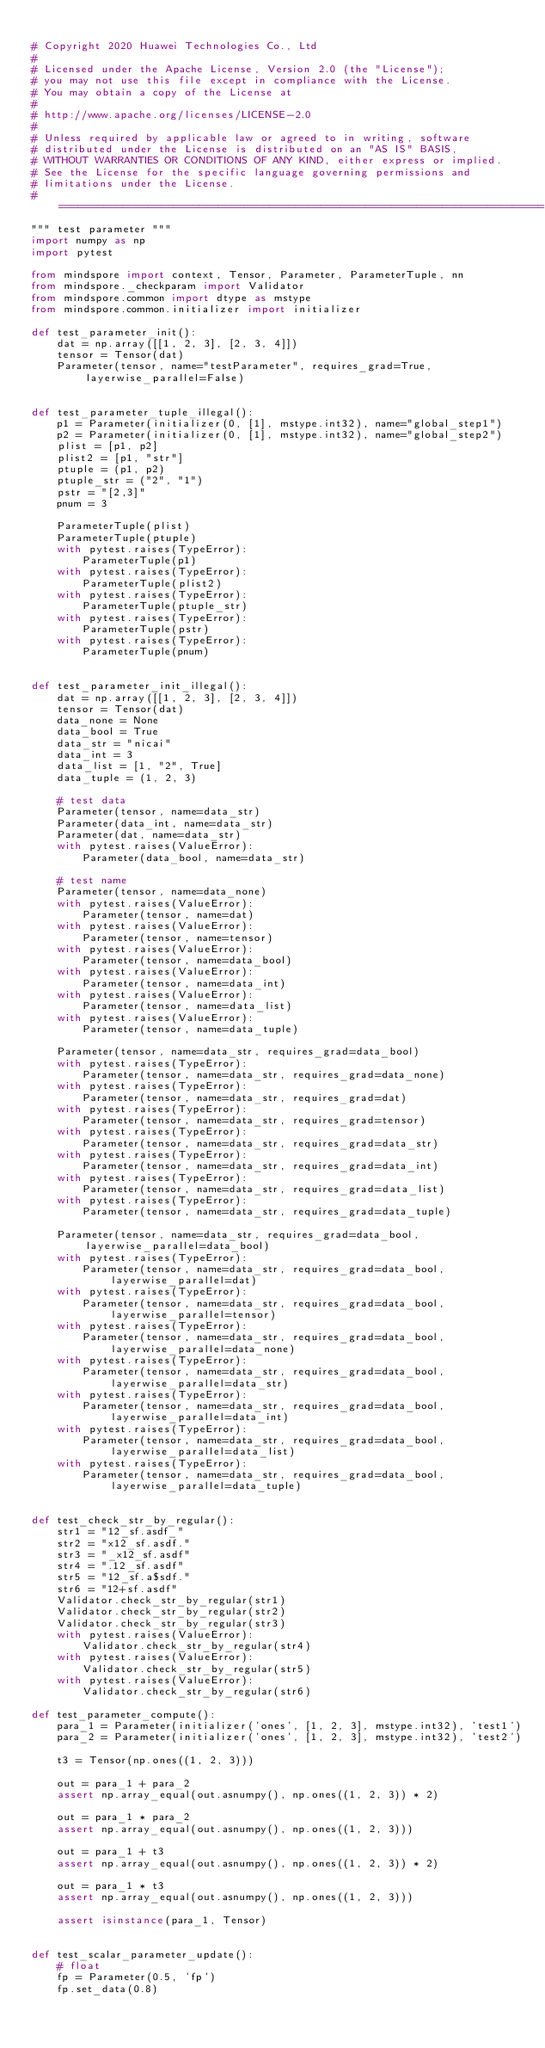<code> <loc_0><loc_0><loc_500><loc_500><_Python_>
# Copyright 2020 Huawei Technologies Co., Ltd
#
# Licensed under the Apache License, Version 2.0 (the "License");
# you may not use this file except in compliance with the License.
# You may obtain a copy of the License at
#
# http://www.apache.org/licenses/LICENSE-2.0
#
# Unless required by applicable law or agreed to in writing, software
# distributed under the License is distributed on an "AS IS" BASIS,
# WITHOUT WARRANTIES OR CONDITIONS OF ANY KIND, either express or implied.
# See the License for the specific language governing permissions and
# limitations under the License.
# ============================================================================
""" test parameter """
import numpy as np
import pytest

from mindspore import context, Tensor, Parameter, ParameterTuple, nn
from mindspore._checkparam import Validator
from mindspore.common import dtype as mstype
from mindspore.common.initializer import initializer

def test_parameter_init():
    dat = np.array([[1, 2, 3], [2, 3, 4]])
    tensor = Tensor(dat)
    Parameter(tensor, name="testParameter", requires_grad=True, layerwise_parallel=False)


def test_parameter_tuple_illegal():
    p1 = Parameter(initializer(0, [1], mstype.int32), name="global_step1")
    p2 = Parameter(initializer(0, [1], mstype.int32), name="global_step2")
    plist = [p1, p2]
    plist2 = [p1, "str"]
    ptuple = (p1, p2)
    ptuple_str = ("2", "1")
    pstr = "[2,3]"
    pnum = 3

    ParameterTuple(plist)
    ParameterTuple(ptuple)
    with pytest.raises(TypeError):
        ParameterTuple(p1)
    with pytest.raises(TypeError):
        ParameterTuple(plist2)
    with pytest.raises(TypeError):
        ParameterTuple(ptuple_str)
    with pytest.raises(TypeError):
        ParameterTuple(pstr)
    with pytest.raises(TypeError):
        ParameterTuple(pnum)


def test_parameter_init_illegal():
    dat = np.array([[1, 2, 3], [2, 3, 4]])
    tensor = Tensor(dat)
    data_none = None
    data_bool = True
    data_str = "nicai"
    data_int = 3
    data_list = [1, "2", True]
    data_tuple = (1, 2, 3)

    # test data
    Parameter(tensor, name=data_str)
    Parameter(data_int, name=data_str)
    Parameter(dat, name=data_str)
    with pytest.raises(ValueError):
        Parameter(data_bool, name=data_str)

    # test name
    Parameter(tensor, name=data_none)
    with pytest.raises(ValueError):
        Parameter(tensor, name=dat)
    with pytest.raises(ValueError):
        Parameter(tensor, name=tensor)
    with pytest.raises(ValueError):
        Parameter(tensor, name=data_bool)
    with pytest.raises(ValueError):
        Parameter(tensor, name=data_int)
    with pytest.raises(ValueError):
        Parameter(tensor, name=data_list)
    with pytest.raises(ValueError):
        Parameter(tensor, name=data_tuple)

    Parameter(tensor, name=data_str, requires_grad=data_bool)
    with pytest.raises(TypeError):
        Parameter(tensor, name=data_str, requires_grad=data_none)
    with pytest.raises(TypeError):
        Parameter(tensor, name=data_str, requires_grad=dat)
    with pytest.raises(TypeError):
        Parameter(tensor, name=data_str, requires_grad=tensor)
    with pytest.raises(TypeError):
        Parameter(tensor, name=data_str, requires_grad=data_str)
    with pytest.raises(TypeError):
        Parameter(tensor, name=data_str, requires_grad=data_int)
    with pytest.raises(TypeError):
        Parameter(tensor, name=data_str, requires_grad=data_list)
    with pytest.raises(TypeError):
        Parameter(tensor, name=data_str, requires_grad=data_tuple)

    Parameter(tensor, name=data_str, requires_grad=data_bool, layerwise_parallel=data_bool)
    with pytest.raises(TypeError):
        Parameter(tensor, name=data_str, requires_grad=data_bool, layerwise_parallel=dat)
    with pytest.raises(TypeError):
        Parameter(tensor, name=data_str, requires_grad=data_bool, layerwise_parallel=tensor)
    with pytest.raises(TypeError):
        Parameter(tensor, name=data_str, requires_grad=data_bool, layerwise_parallel=data_none)
    with pytest.raises(TypeError):
        Parameter(tensor, name=data_str, requires_grad=data_bool, layerwise_parallel=data_str)
    with pytest.raises(TypeError):
        Parameter(tensor, name=data_str, requires_grad=data_bool, layerwise_parallel=data_int)
    with pytest.raises(TypeError):
        Parameter(tensor, name=data_str, requires_grad=data_bool, layerwise_parallel=data_list)
    with pytest.raises(TypeError):
        Parameter(tensor, name=data_str, requires_grad=data_bool, layerwise_parallel=data_tuple)


def test_check_str_by_regular():
    str1 = "12_sf.asdf_"
    str2 = "x12_sf.asdf."
    str3 = "_x12_sf.asdf"
    str4 = ".12_sf.asdf"
    str5 = "12_sf.a$sdf."
    str6 = "12+sf.asdf"
    Validator.check_str_by_regular(str1)
    Validator.check_str_by_regular(str2)
    Validator.check_str_by_regular(str3)
    with pytest.raises(ValueError):
        Validator.check_str_by_regular(str4)
    with pytest.raises(ValueError):
        Validator.check_str_by_regular(str5)
    with pytest.raises(ValueError):
        Validator.check_str_by_regular(str6)

def test_parameter_compute():
    para_1 = Parameter(initializer('ones', [1, 2, 3], mstype.int32), 'test1')
    para_2 = Parameter(initializer('ones', [1, 2, 3], mstype.int32), 'test2')

    t3 = Tensor(np.ones((1, 2, 3)))

    out = para_1 + para_2
    assert np.array_equal(out.asnumpy(), np.ones((1, 2, 3)) * 2)

    out = para_1 * para_2
    assert np.array_equal(out.asnumpy(), np.ones((1, 2, 3)))

    out = para_1 + t3
    assert np.array_equal(out.asnumpy(), np.ones((1, 2, 3)) * 2)

    out = para_1 * t3
    assert np.array_equal(out.asnumpy(), np.ones((1, 2, 3)))

    assert isinstance(para_1, Tensor)


def test_scalar_parameter_update():
    # float
    fp = Parameter(0.5, 'fp')
    fp.set_data(0.8)</code> 